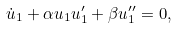Convert formula to latex. <formula><loc_0><loc_0><loc_500><loc_500>\dot { u } _ { 1 } + \alpha u _ { 1 } u ^ { \prime } _ { 1 } + \beta u ^ { \prime \prime } _ { 1 } = 0 ,</formula> 